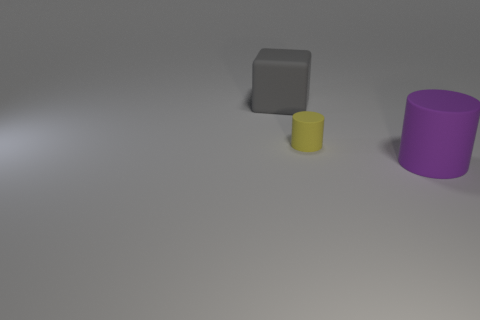Add 1 small red blocks. How many objects exist? 4 Subtract all cylinders. How many objects are left? 1 Subtract all gray matte cubes. Subtract all large purple cylinders. How many objects are left? 1 Add 1 large cylinders. How many large cylinders are left? 2 Add 2 large rubber blocks. How many large rubber blocks exist? 3 Subtract 1 yellow cylinders. How many objects are left? 2 